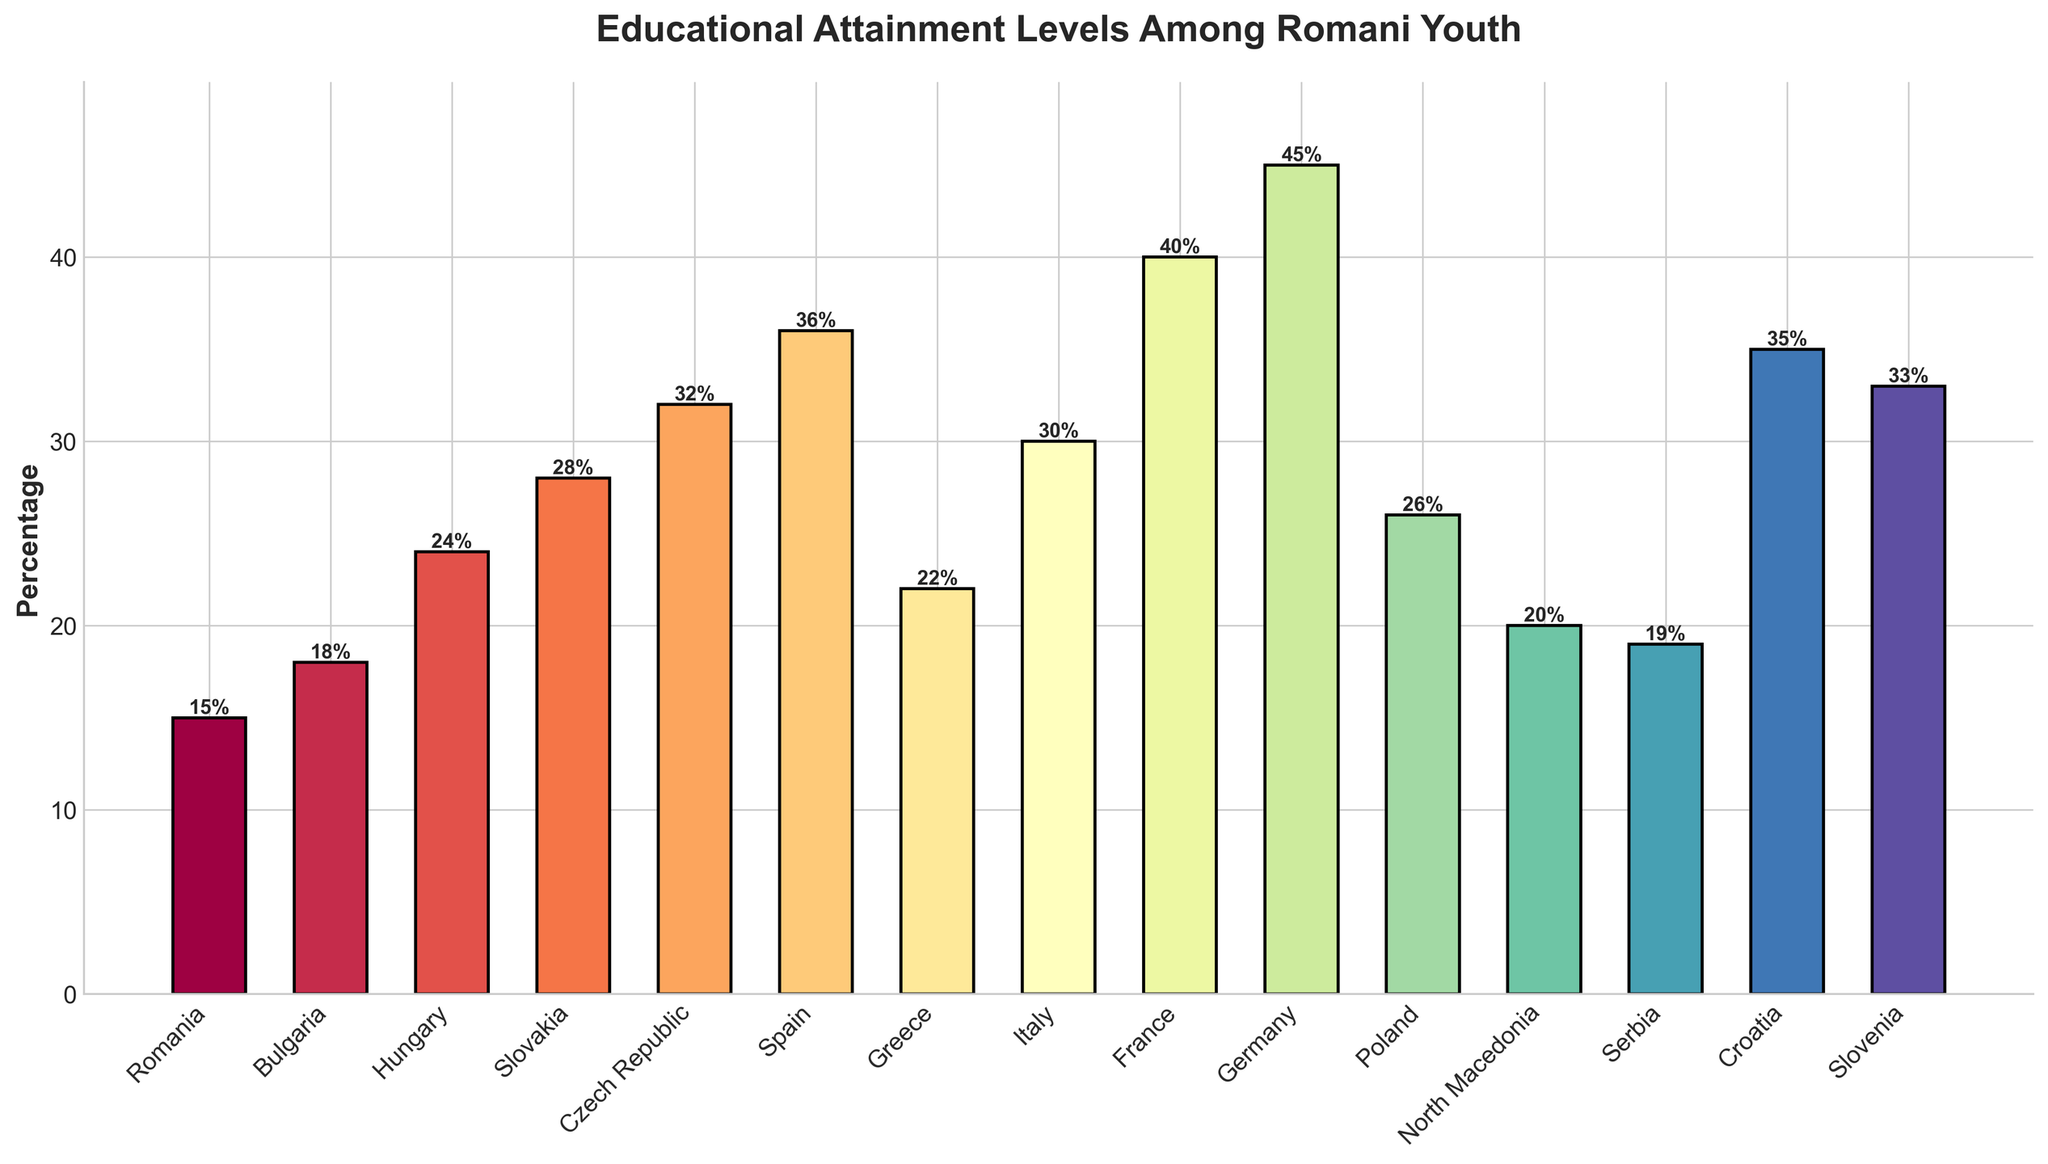Which country has the highest percentage of Romani youth completing secondary education? To find the country with the highest percentage, look for the tallest bar in the bar chart. The bar corresponding to Germany is the tallest, indicating the highest percentage.
Answer: Germany Which countries have a higher percentage of Romani youth completing secondary education compared to Bulgaria? Identify Bulgaria's bar at 18% and compare it to the other bars. Countries with a higher percentage include Hungary, Slovakia, Czech Republic, Spain, Greece, Italy, France, Germany, Poland, Croatia, and Slovenia.
Answer: Hungary, Slovakia, Czech Republic, Spain, Greece, Italy, France, Germany, Poland, Croatia, Slovenia What is the difference in the percentage of Romani youth completing secondary education between Italy and France? Locate the heights of the Italy and France bars, which are 30% and 40% respectively. The difference is calculated as 40% - 30%.
Answer: 10% What is the average percentage of Romani youth completing secondary education in Romania, Bulgaria, and North Macedonia? Find the percentages for Romania (15%), Bulgaria (18%), and North Macedonia (20%). Calculate the sum (15 + 18 + 20 = 53) and then the average (53/3).
Answer: 17.67% Which country has a lower percentage of Romani youth completing secondary education, Serbia or Greece? Compare the heights of the bars for Serbia (19%) and Greece (22%). The lower percentage is for Serbia.
Answer: Serbia In which country do Romani youth have a secondary education completion rate closest to 34%? Look at the heights of the bars around 34%. Croatia and Slovenia are close with values of 35% and 33% respectively. The closest country, Slovenia, has a 33% rate.
Answer: Slovenia Which countries have a percentage of Romani youth completing secondary education above the average of the given dataset? Calculate the average percentage of the given data points: (15 + 18 + 24 + 28 + 32 + 36 + 22 + 30 + 40 + 45 + 26 + 20 + 19 + 35 + 33) / 15 = 27.6%. Countries above this include Czech Republic, Spain, Italy, France, Germany, Croatia, and Slovenia.
Answer: Czech Republic, Spain, Italy, France, Germany, Croatia, Slovenia What is the range of percentages of Romani youth completing secondary education in the dataset? Identify the minimum (Romania, 15%) and maximum (Germany, 45%) values and calculate the range as 45% - 15%.
Answer: 30% Which countries have exactly five countries with a higher percentage of Romani youth completing secondary education than theirs? Check the countries to see which has five countries with a higher percentage. Italy has Germany, France, Croatia, Slovenia, and Spain above it.
Answer: Italy 